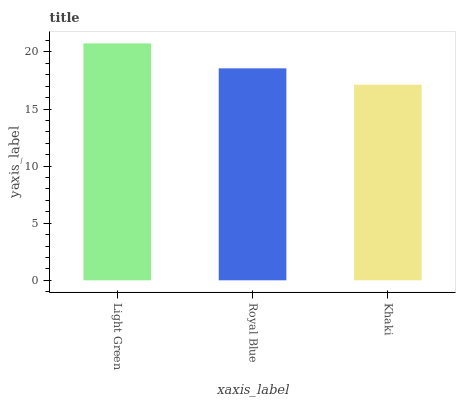Is Khaki the minimum?
Answer yes or no. Yes. Is Light Green the maximum?
Answer yes or no. Yes. Is Royal Blue the minimum?
Answer yes or no. No. Is Royal Blue the maximum?
Answer yes or no. No. Is Light Green greater than Royal Blue?
Answer yes or no. Yes. Is Royal Blue less than Light Green?
Answer yes or no. Yes. Is Royal Blue greater than Light Green?
Answer yes or no. No. Is Light Green less than Royal Blue?
Answer yes or no. No. Is Royal Blue the high median?
Answer yes or no. Yes. Is Royal Blue the low median?
Answer yes or no. Yes. Is Light Green the high median?
Answer yes or no. No. Is Light Green the low median?
Answer yes or no. No. 